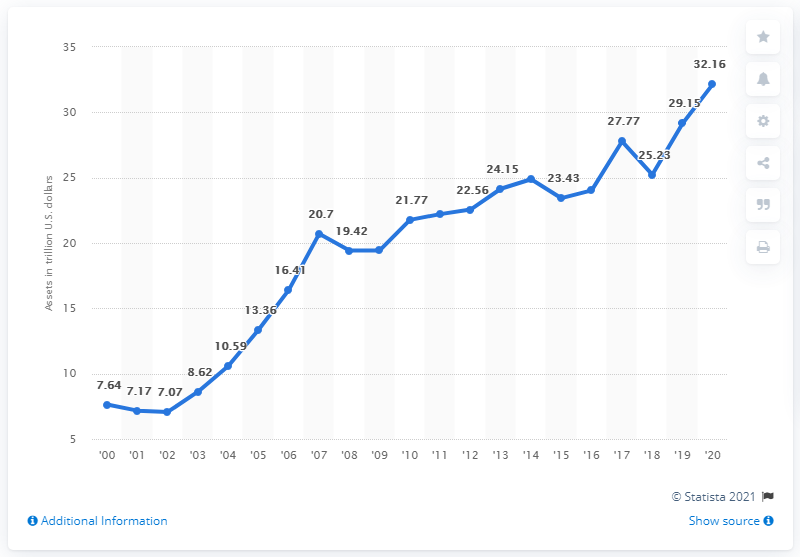Indicate a few pertinent items in this graphic. The total amount of U.S.-owned assets abroad in 2019 was approximately 29.15. The value of U.S.-owned assets abroad at the end of 2020 was 32.16 trillion dollars. As of 2009, the value of U.S.-owned assets abroad totaled 19.43... 